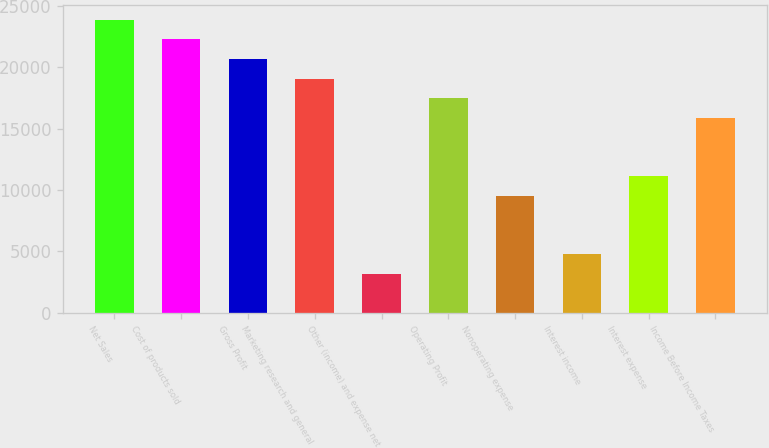<chart> <loc_0><loc_0><loc_500><loc_500><bar_chart><fcel>Net Sales<fcel>Cost of products sold<fcel>Gross Profit<fcel>Marketing research and general<fcel>Other (income) and expense net<fcel>Operating Profit<fcel>Nonoperating expense<fcel>Interest income<fcel>Interest expense<fcel>Income Before Income Taxes<nl><fcel>23852.2<fcel>22262.3<fcel>20672.4<fcel>19082.5<fcel>3183.16<fcel>17492.5<fcel>9542.88<fcel>4773.09<fcel>11132.8<fcel>15902.6<nl></chart> 